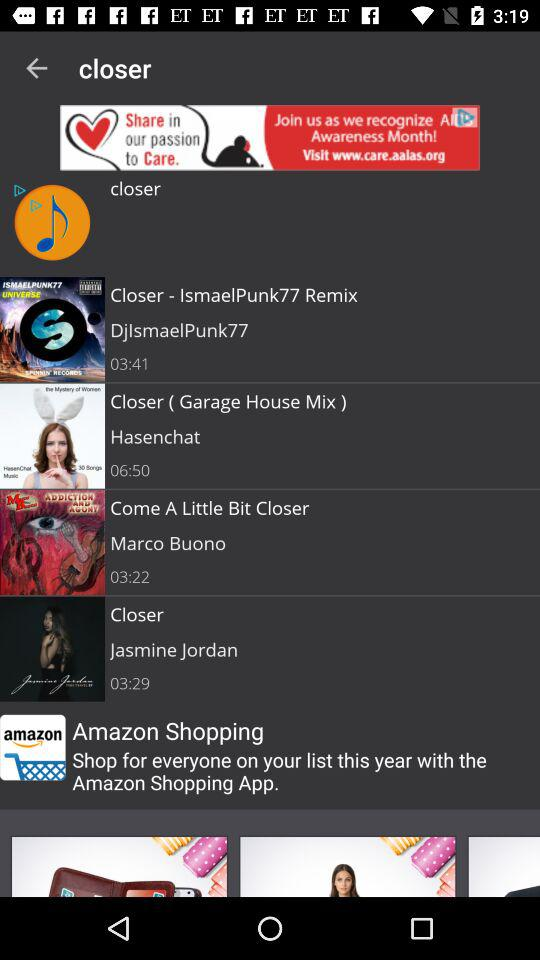Which song was sung by Hasenchat? Hasenchat is the artist behind the song titled 'Closer (Garage House Mix).' This track appears as packed with engaging beats typical of the Garage House genre and expands over a duration of 6 minutes and 50 seconds, offering an immersive experience. 